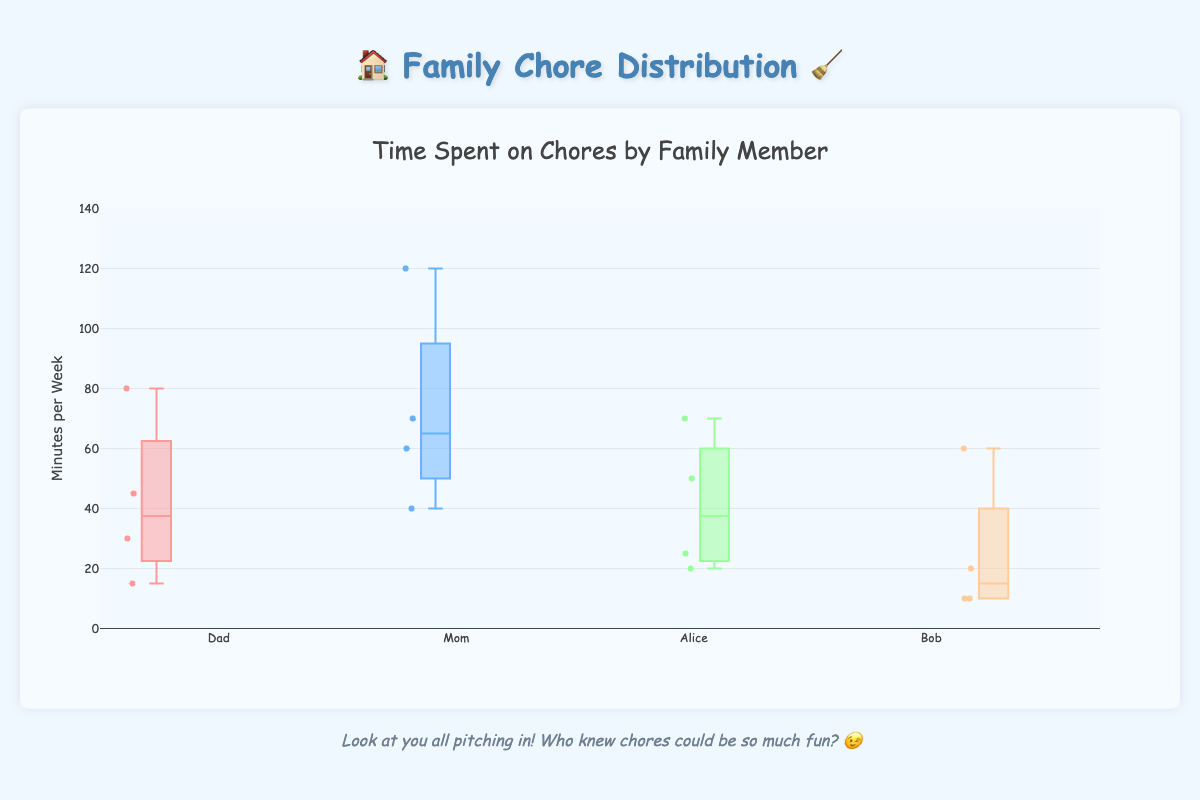How many chores are displayed in the figure? Count the distinct chore types shown as labels on the x-axis.
Answer: 4 What chore does Bob spend the most time on per week? Look at the distribution of minutes for Bob across all chores and identify the highest value. Bob spends the most time on "Dishes" with 60 minutes per week.
Answer: Dishes Who spends more time on laundry, Dad or Mom? Compare the minutes spent on laundry between Dad and Mom by looking at their respective boxes in the plot. Mom spends 60 minutes while Dad spends only 15 minutes on laundry.
Answer: Mom What's the median value for minutes spent on dishes? For the "Dishes" chore, identify the median line within each member's box. Since Mom has the highest median for dishes (at 120 minutes), the overall median should be noted across all boxes for comparison.
Answer: 75 minutes Who spends the least time on vacuuming? Compare the lower whiskers of the boxes representing vacuuming minutes for each family member. Bob spends the least time on vacuuming with 20 minutes per week.
Answer: Bob What is the Interquartile Range (IQR) for Alice with the grocery shopping chore? Identify the difference between the third quartile (Q3) and the first quartile (Q1) for Alice in the grocery shopping box. Find the ends of the box for Alice and calculate the IQR as Q3 - Q1.
Answer: 10 minutes Which family member has the largest range of time spent on chores? Determine the range for each member by finding the difference between the maximum and minimum values in their respective boxes. Compare these ranges to find the largest. Mom has the largest range, from 60 to 120 minutes for dishes.
Answer: Mom How does the time spent on vacuuming by Dad compare to Bob? Compare the median or the box height of Dad's vacuuming to Bob's. Dad's median time spent on vacuuming (about 30 minutes) is significantly higher than Bob's (20 minutes).
Answer: Dad spends more time on vacuuming What is the average time spent on chores by Alice? List the times Alice spends on each chore and calculate the average: (70 + 50 + 25 + 20) / 4 = 165 / 4.
Answer: 41.25 minutes per chore Which chore shows the most variability in time spent among family members? Examine the spread (length of the boxes and whiskers) for each chore along the x-axis. Dishes have the most variability, with a range of 60 to 120 minutes and interquartile spreads varying significantly.
Answer: Dishes 